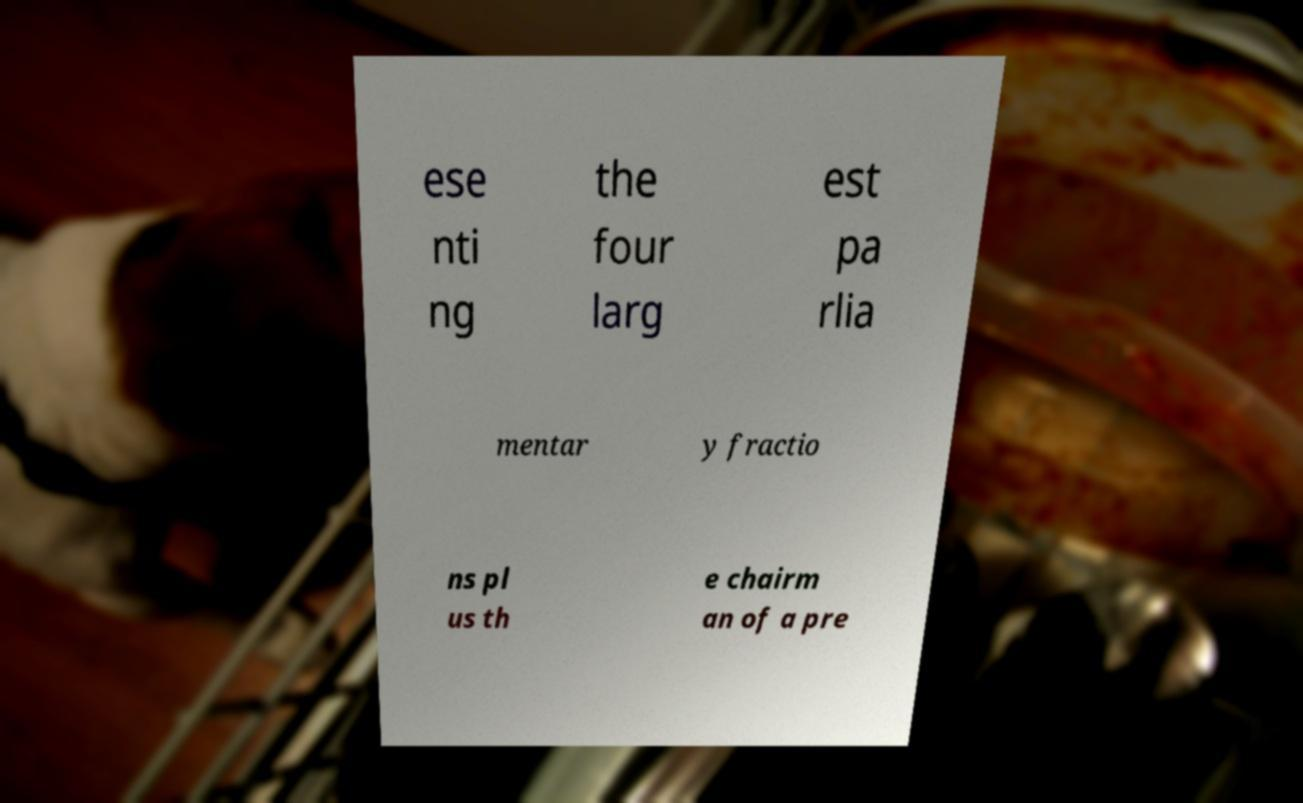Please read and relay the text visible in this image. What does it say? ese nti ng the four larg est pa rlia mentar y fractio ns pl us th e chairm an of a pre 